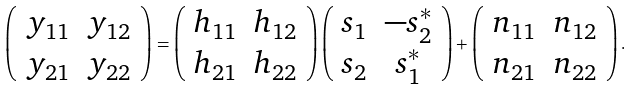Convert formula to latex. <formula><loc_0><loc_0><loc_500><loc_500>\left ( \begin{array} { c c } y _ { 1 1 } & y _ { 1 2 } \\ y _ { 2 1 } & y _ { 2 2 } \end{array} \right ) = \left ( \begin{array} { c c } h _ { 1 1 } & h _ { 1 2 } \\ h _ { 2 1 } & h _ { 2 2 } \end{array} \right ) \left ( \begin{array} { c c } s _ { 1 } & - s ^ { * } _ { 2 } \\ s _ { 2 } & s ^ { * } _ { 1 } \end{array} \right ) + \left ( \begin{array} { c c } n _ { 1 1 } & n _ { 1 2 } \\ n _ { 2 1 } & n _ { 2 2 } \end{array} \right ) .</formula> 